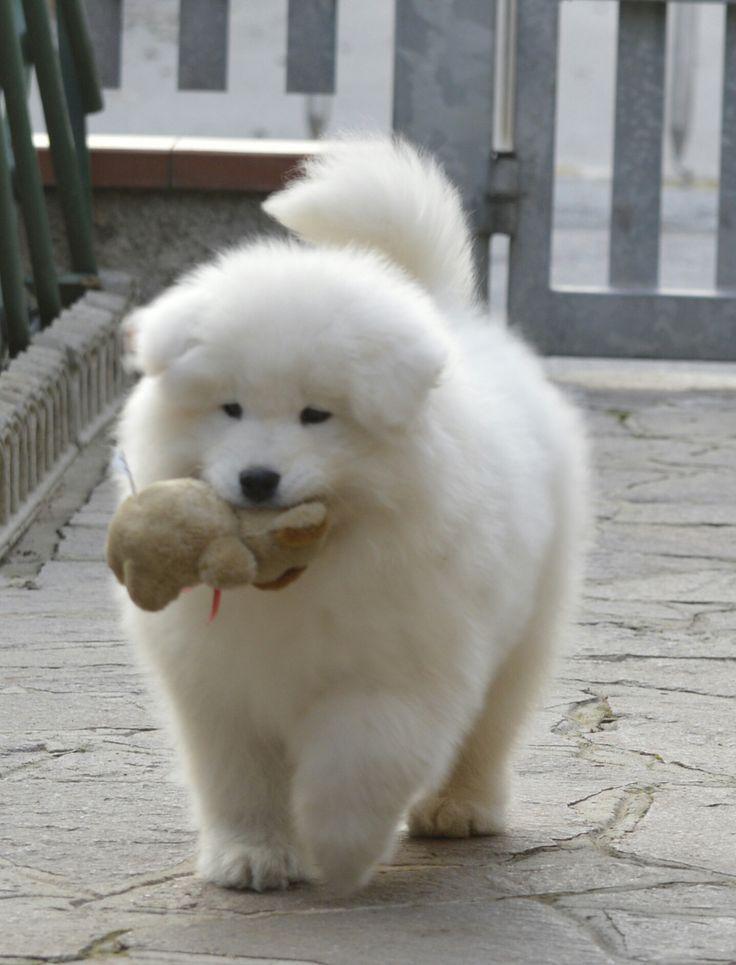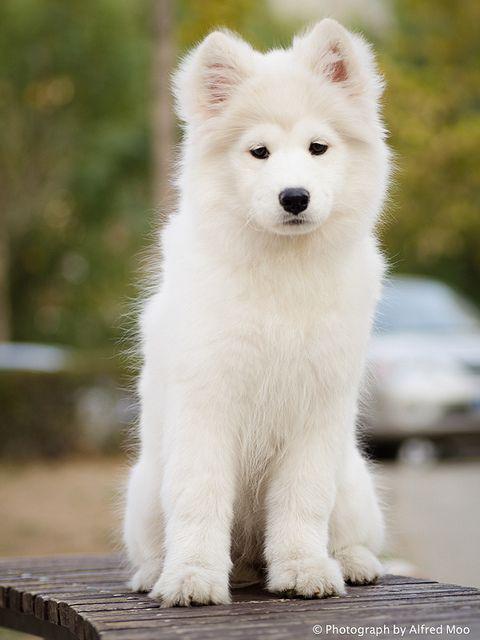The first image is the image on the left, the second image is the image on the right. For the images shown, is this caption "Atleast one picture of a single dog posing on grass" true? Answer yes or no. No. The first image is the image on the left, the second image is the image on the right. For the images displayed, is the sentence "At least one of the images features a puppy without an adult." factually correct? Answer yes or no. Yes. 